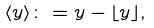Convert formula to latex. <formula><loc_0><loc_0><loc_500><loc_500>\langle y \rangle \colon = y - \lfloor y \rfloor ,</formula> 